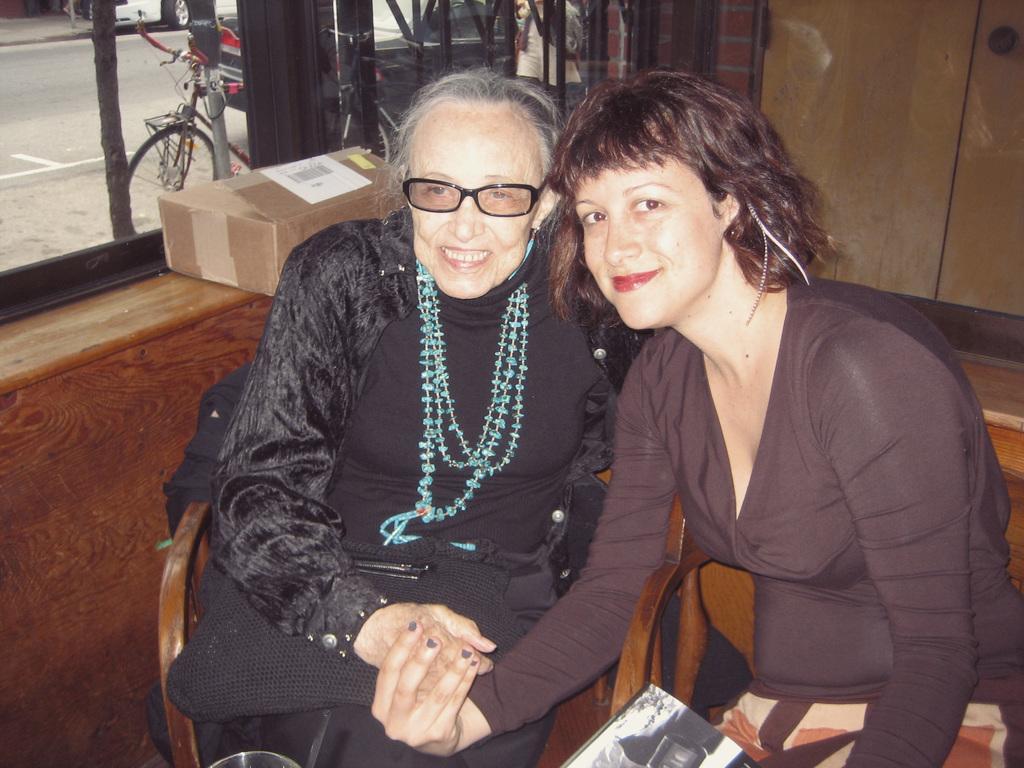Describe this image in one or two sentences. In the image there are two women in the foreground, behind them there is a cupboard and on the left side there is a window and behind the window there are vehicles. 